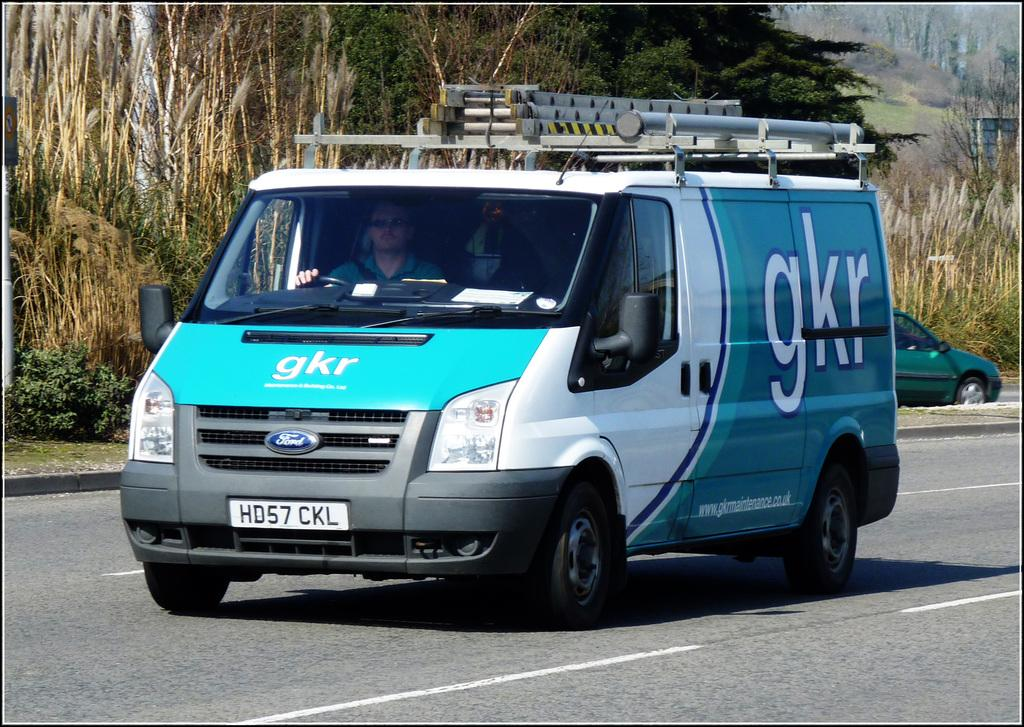<image>
Create a compact narrative representing the image presented. A gkr van is driving down the road. 